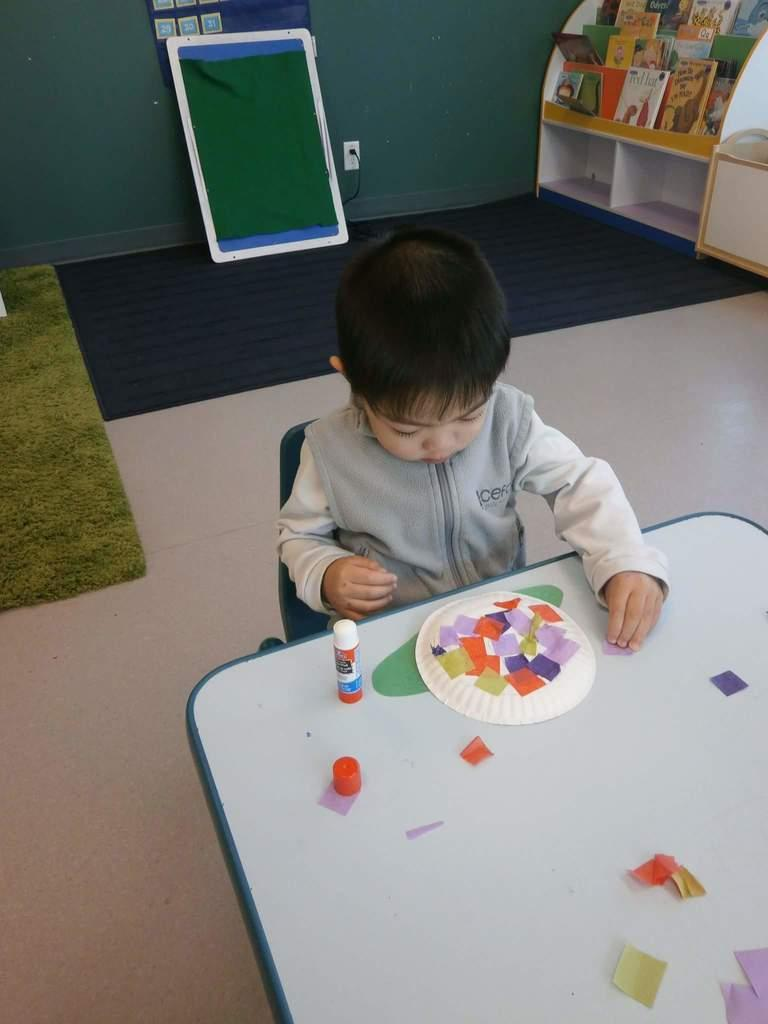What is the main subject of the image? The main subject of the image is a kid. What is the kid doing in the image? The kid is playing in the image. Where is the kid sitting in the image? The kid is sitting in a chair in the image. What is near the chair in the image? The chair is near a table in the image. What type of bird can be seen in the middle of the image? There is no bird present in the image. Is the kid playing quietly in the image? The provided facts do not mention the volume of the kid's play, so we cannot determine if they are playing quietly or not. 